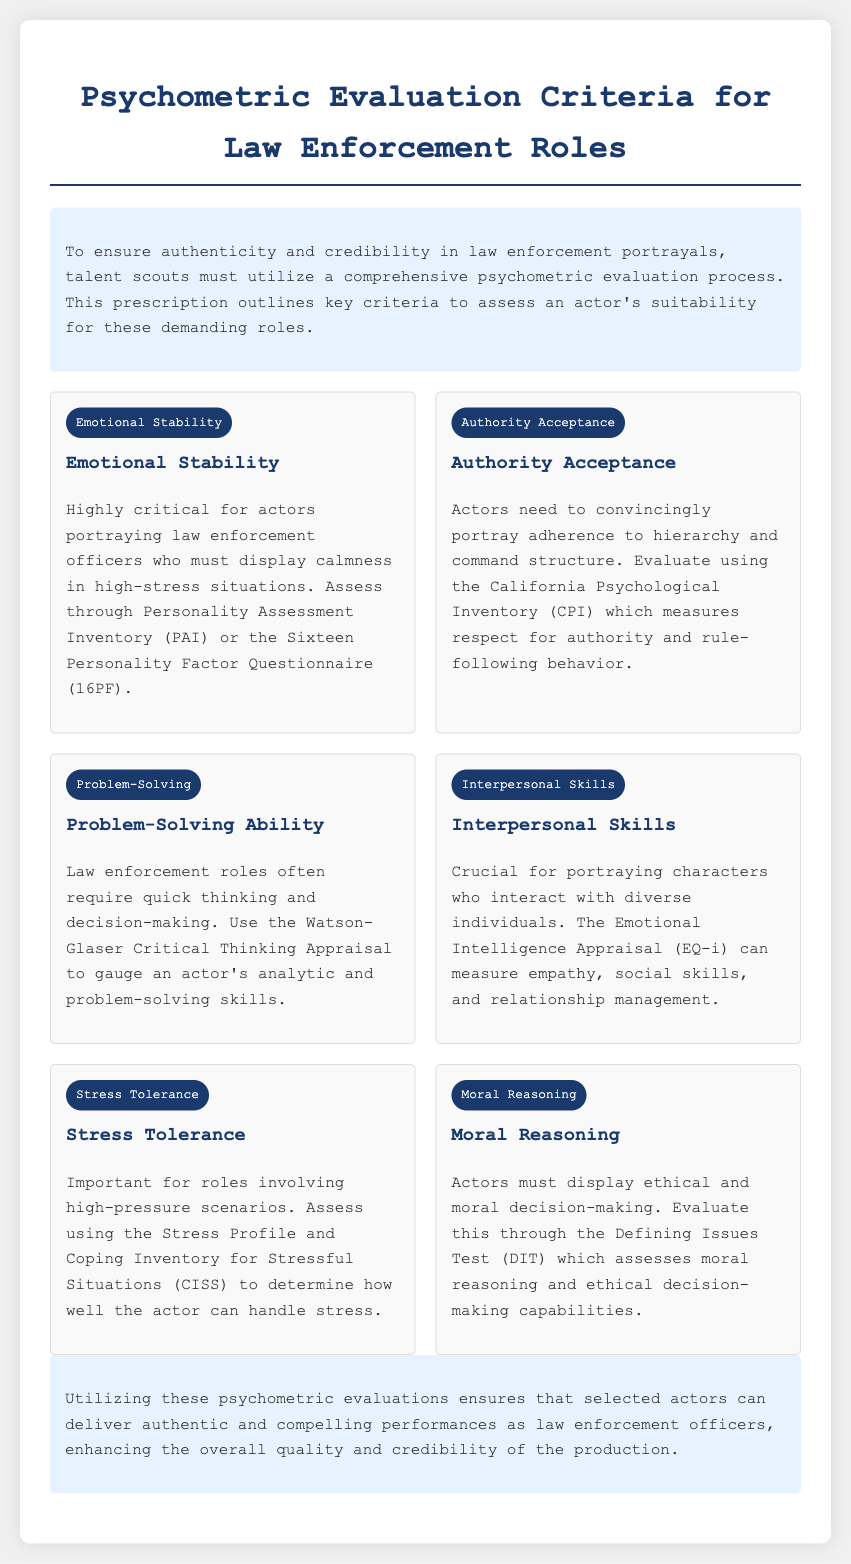What is the title of the document? The title of the document is found in the header section, which declares the purpose of the document.
Answer: Psychometric Evaluation for Law Enforcement Roles What is the first criterion listed? The first criterion is found in the criteria section, listed at the top.
Answer: Emotional Stability What evaluation tool assesses Authority Acceptance? The document specifies the tool to evaluate Authority Acceptance under the corresponding criterion.
Answer: California Psychological Inventory What skill does the Watson-Glaser Critical Thinking Appraisal measure? The document clearly states that this tool is used to gauge analytical and problem-solving skills.
Answer: Problem-Solving Ability How many key criteria are outlined in the document? The number of criteria is discernible by counting the sections under the criteria part of the document.
Answer: Six Which criterion focuses on ethical decision-making? The document identifies this criterion among the listed assessments regarding moral decision-making.
Answer: Moral Reasoning What type of skills does the Emotional Intelligence Appraisal assess? The document specifies what aspect of interpersonal abilities this appraisal targets.
Answer: Interpersonal Skills What is the purpose of this psychometric evaluation? The document states the overall aim of using these evaluations for actors portraying law enforcement roles.
Answer: Ensure authenticity and credibility 